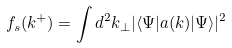Convert formula to latex. <formula><loc_0><loc_0><loc_500><loc_500>f _ { s } ( k ^ { + } ) = \int d ^ { 2 } k _ { \perp } | \langle \Psi | a ( { k } ) | \Psi \rangle | ^ { 2 }</formula> 